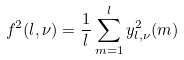<formula> <loc_0><loc_0><loc_500><loc_500>f ^ { 2 } ( l , \nu ) = \frac { 1 } { l } \sum ^ { l } _ { m = 1 } y ^ { 2 } _ { l , \nu } ( m )</formula> 